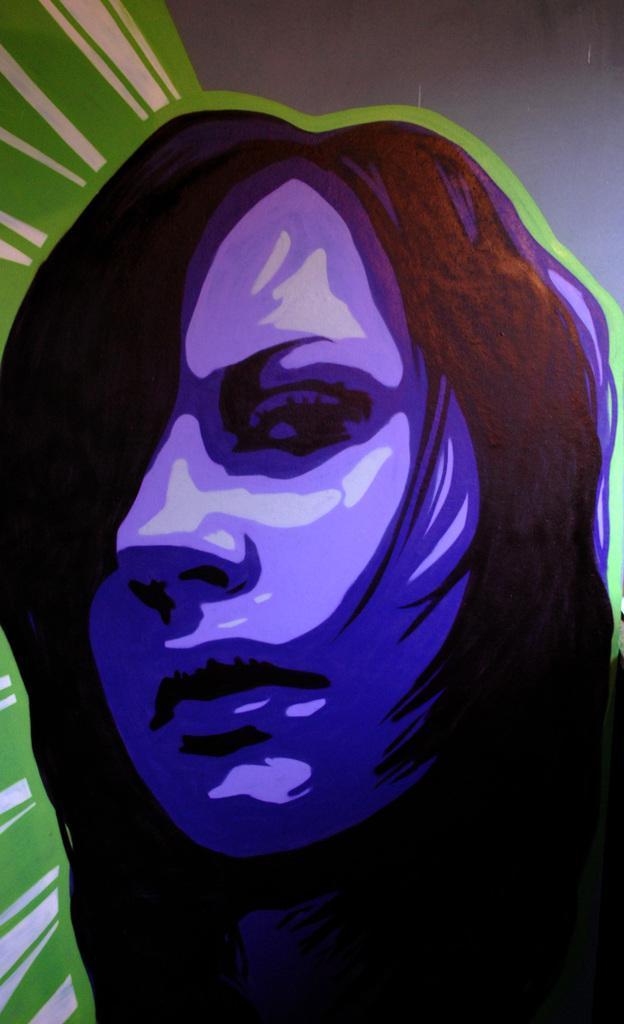Can you describe this image briefly? In this image I can see a woman's animated picture. On the top I can see ash and green color. This image is an animated picture. 